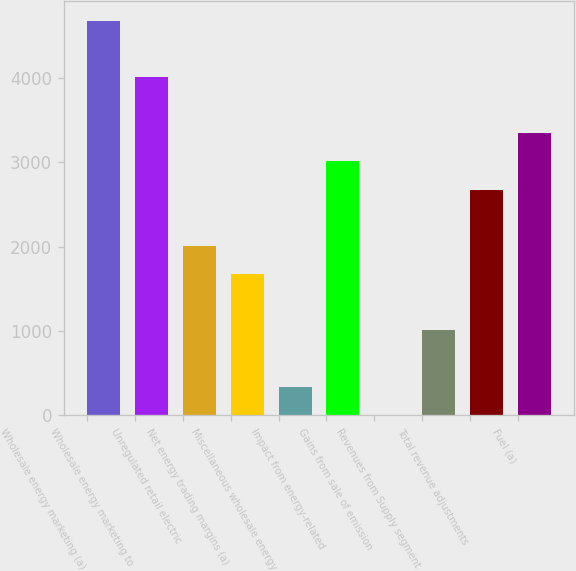Convert chart. <chart><loc_0><loc_0><loc_500><loc_500><bar_chart><fcel>Wholesale energy marketing (a)<fcel>Wholesale energy marketing to<fcel>Unregulated retail electric<fcel>Net energy trading margins (a)<fcel>Miscellaneous wholesale energy<fcel>Impact from energy-related<fcel>Gains from sale of emission<fcel>Revenues from Supply segment<fcel>Total revenue adjustments<fcel>Fuel (a)<nl><fcel>4679.2<fcel>4011.6<fcel>2008.8<fcel>1675<fcel>339.8<fcel>3010.2<fcel>6<fcel>1007.4<fcel>2676.4<fcel>3344<nl></chart> 